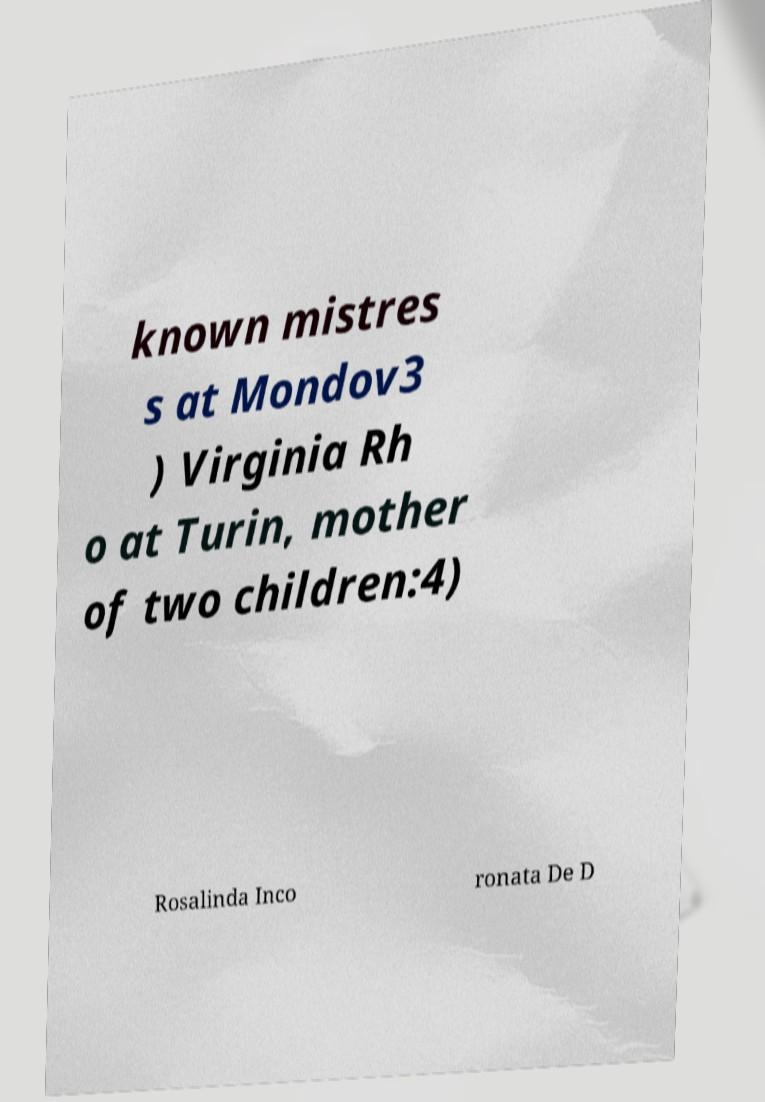For documentation purposes, I need the text within this image transcribed. Could you provide that? known mistres s at Mondov3 ) Virginia Rh o at Turin, mother of two children:4) Rosalinda Inco ronata De D 